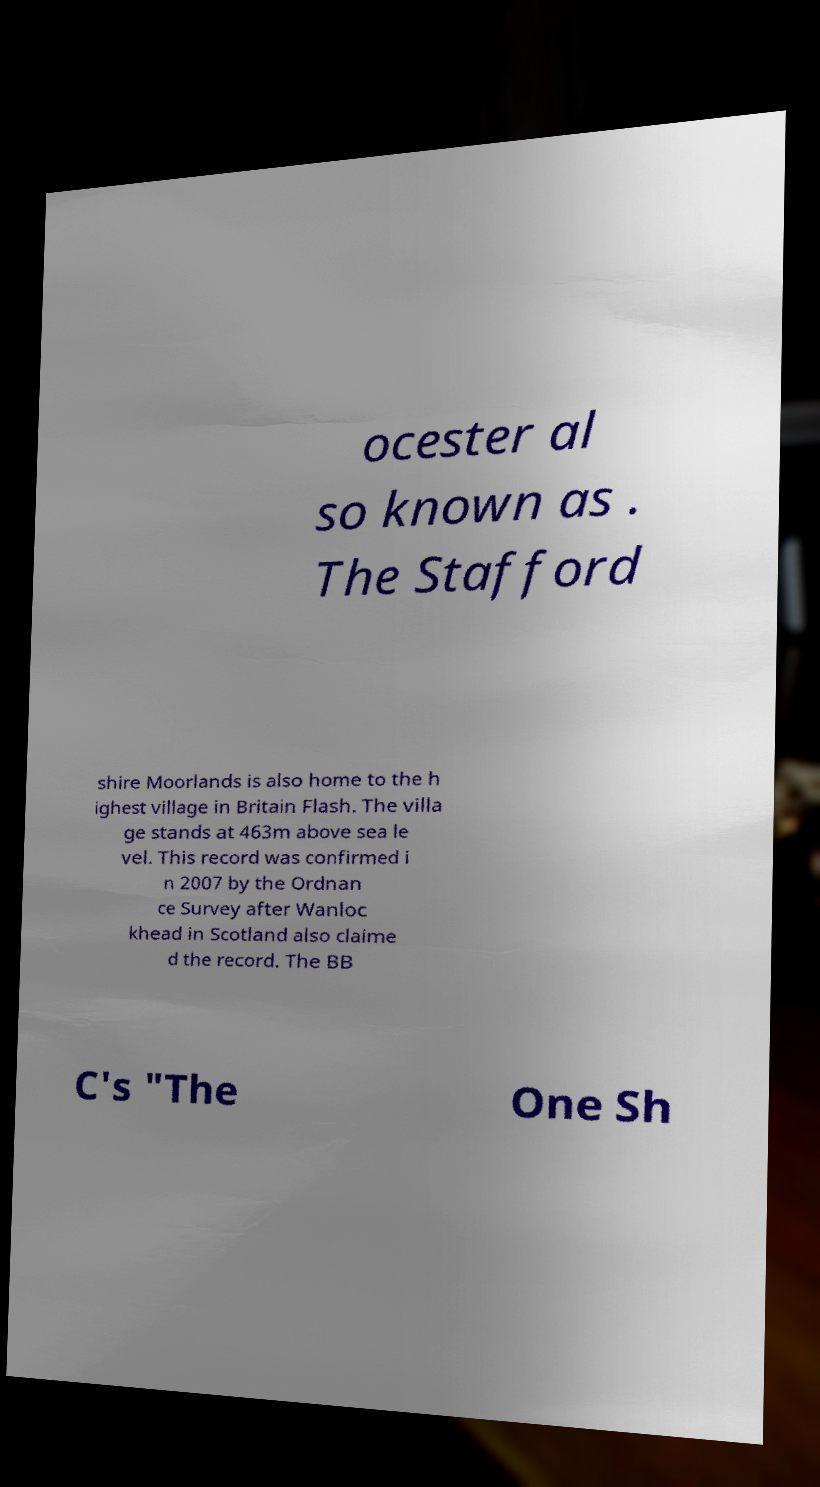I need the written content from this picture converted into text. Can you do that? ocester al so known as . The Stafford shire Moorlands is also home to the h ighest village in Britain Flash. The villa ge stands at 463m above sea le vel. This record was confirmed i n 2007 by the Ordnan ce Survey after Wanloc khead in Scotland also claime d the record. The BB C's "The One Sh 